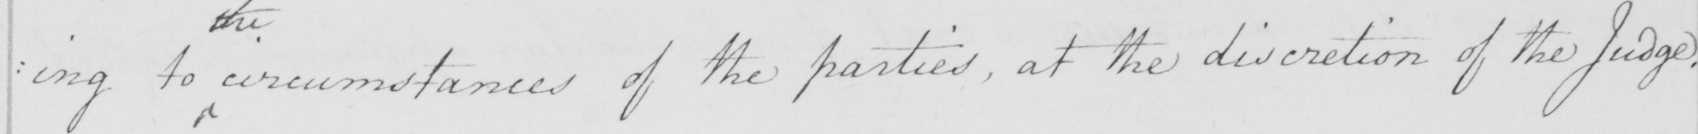Can you tell me what this handwritten text says? : ing to circumstances of the parties , at the discretion of the Judge . 